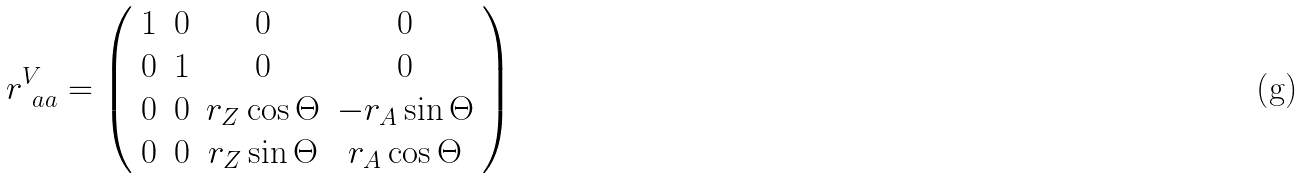<formula> <loc_0><loc_0><loc_500><loc_500>r ^ { V } _ { \ a a } = \left ( \begin{array} { c c c c } 1 & 0 & 0 & 0 \\ 0 & 1 & 0 & 0 \\ 0 & 0 & r _ { Z } \cos \Theta & - r _ { A } \sin \Theta \\ 0 & 0 & r _ { Z } \sin \Theta & r _ { A } \cos \Theta \end{array} \right )</formula> 